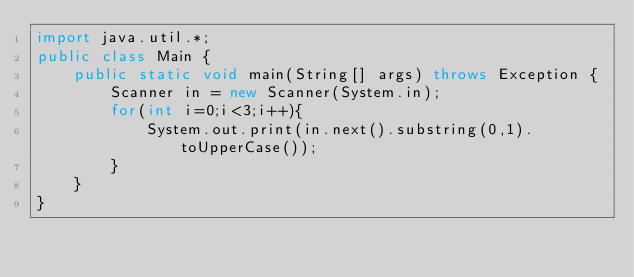<code> <loc_0><loc_0><loc_500><loc_500><_Java_>import java.util.*;
public class Main {
    public static void main(String[] args) throws Exception {
        Scanner in = new Scanner(System.in);
        for(int i=0;i<3;i++){
            System.out.print(in.next().substring(0,1).toUpperCase());
        }
    }
}
</code> 